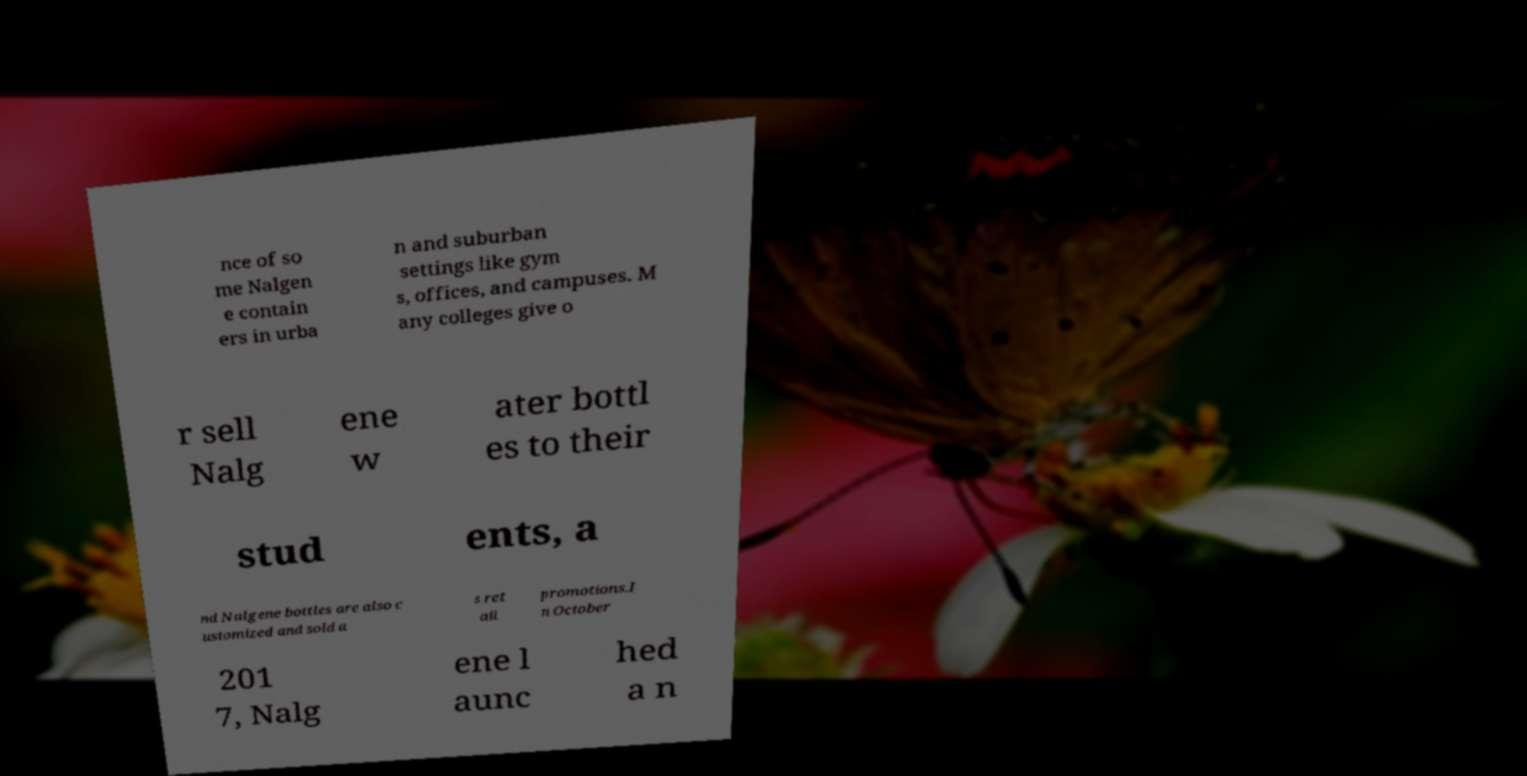What messages or text are displayed in this image? I need them in a readable, typed format. nce of so me Nalgen e contain ers in urba n and suburban settings like gym s, offices, and campuses. M any colleges give o r sell Nalg ene w ater bottl es to their stud ents, a nd Nalgene bottles are also c ustomized and sold a s ret ail promotions.I n October 201 7, Nalg ene l aunc hed a n 